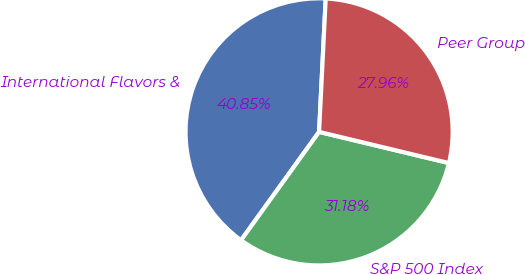Convert chart to OTSL. <chart><loc_0><loc_0><loc_500><loc_500><pie_chart><fcel>International Flavors &<fcel>S&P 500 Index<fcel>Peer Group<nl><fcel>40.85%<fcel>31.18%<fcel>27.96%<nl></chart> 